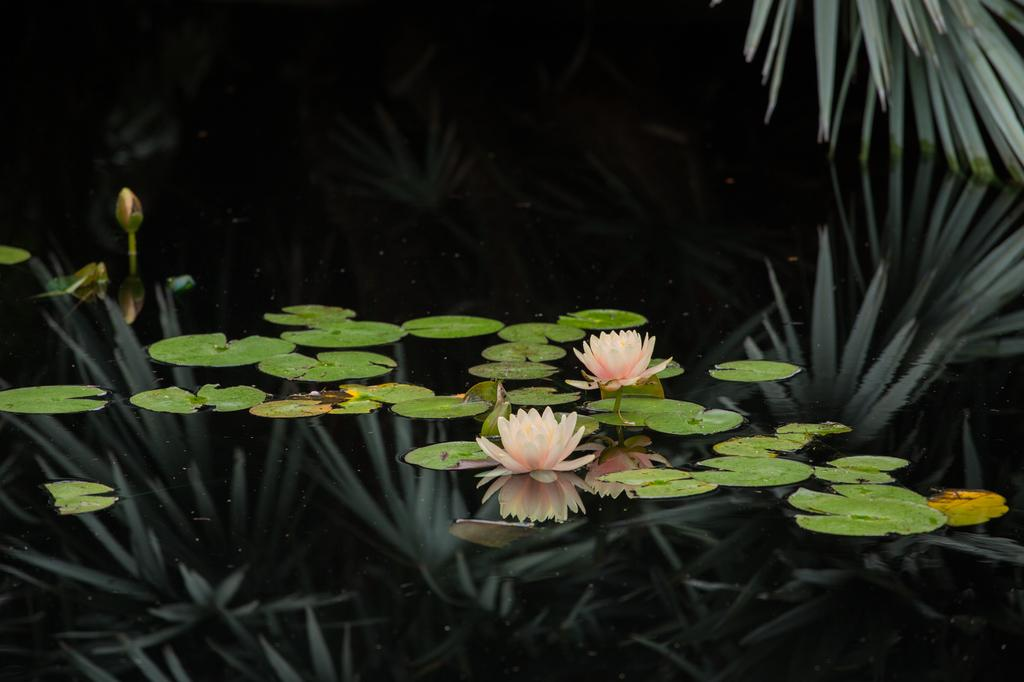What type of plant life is visible in the image? There are flowers, a bud, and leaves in the image. Can you describe the stage of the bud in the image? The bud is in the image, but its stage of development is not specified. What is the relationship between the leaves and the water in the image? The leaves are in the water in the image. Where are additional leaves located in the image? There are leaves in the top right corner of the image. What type of bell can be heard ringing in the image? There is no bell present in the image, and therefore no sound can be heard. 